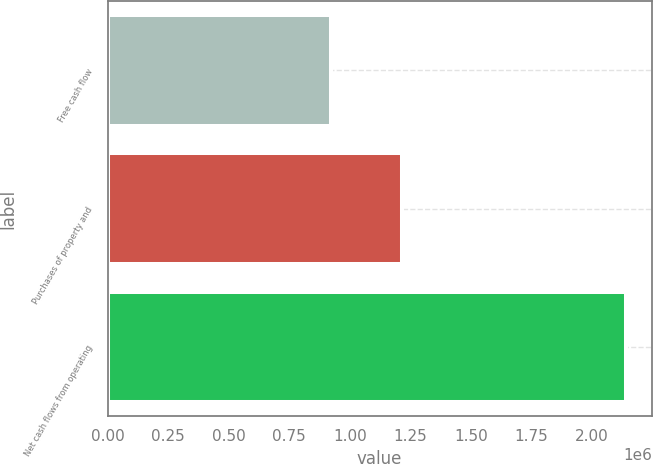<chart> <loc_0><loc_0><loc_500><loc_500><bar_chart><fcel>Free cash flow<fcel>Purchases of property and<fcel>Net cash flows from operating<nl><fcel>923670<fcel>1.21613e+06<fcel>2.1398e+06<nl></chart> 